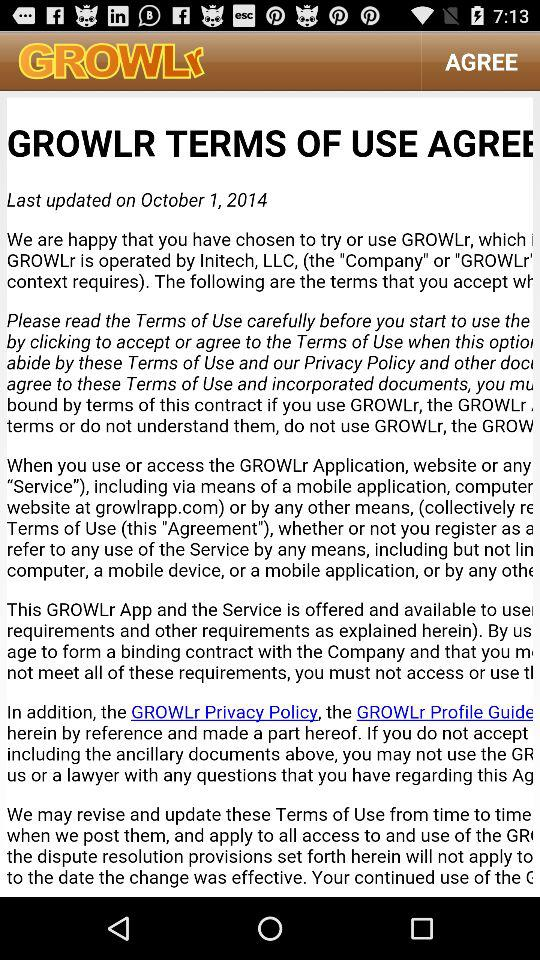What is the name of the application? The name of the application is "GROWLr". 